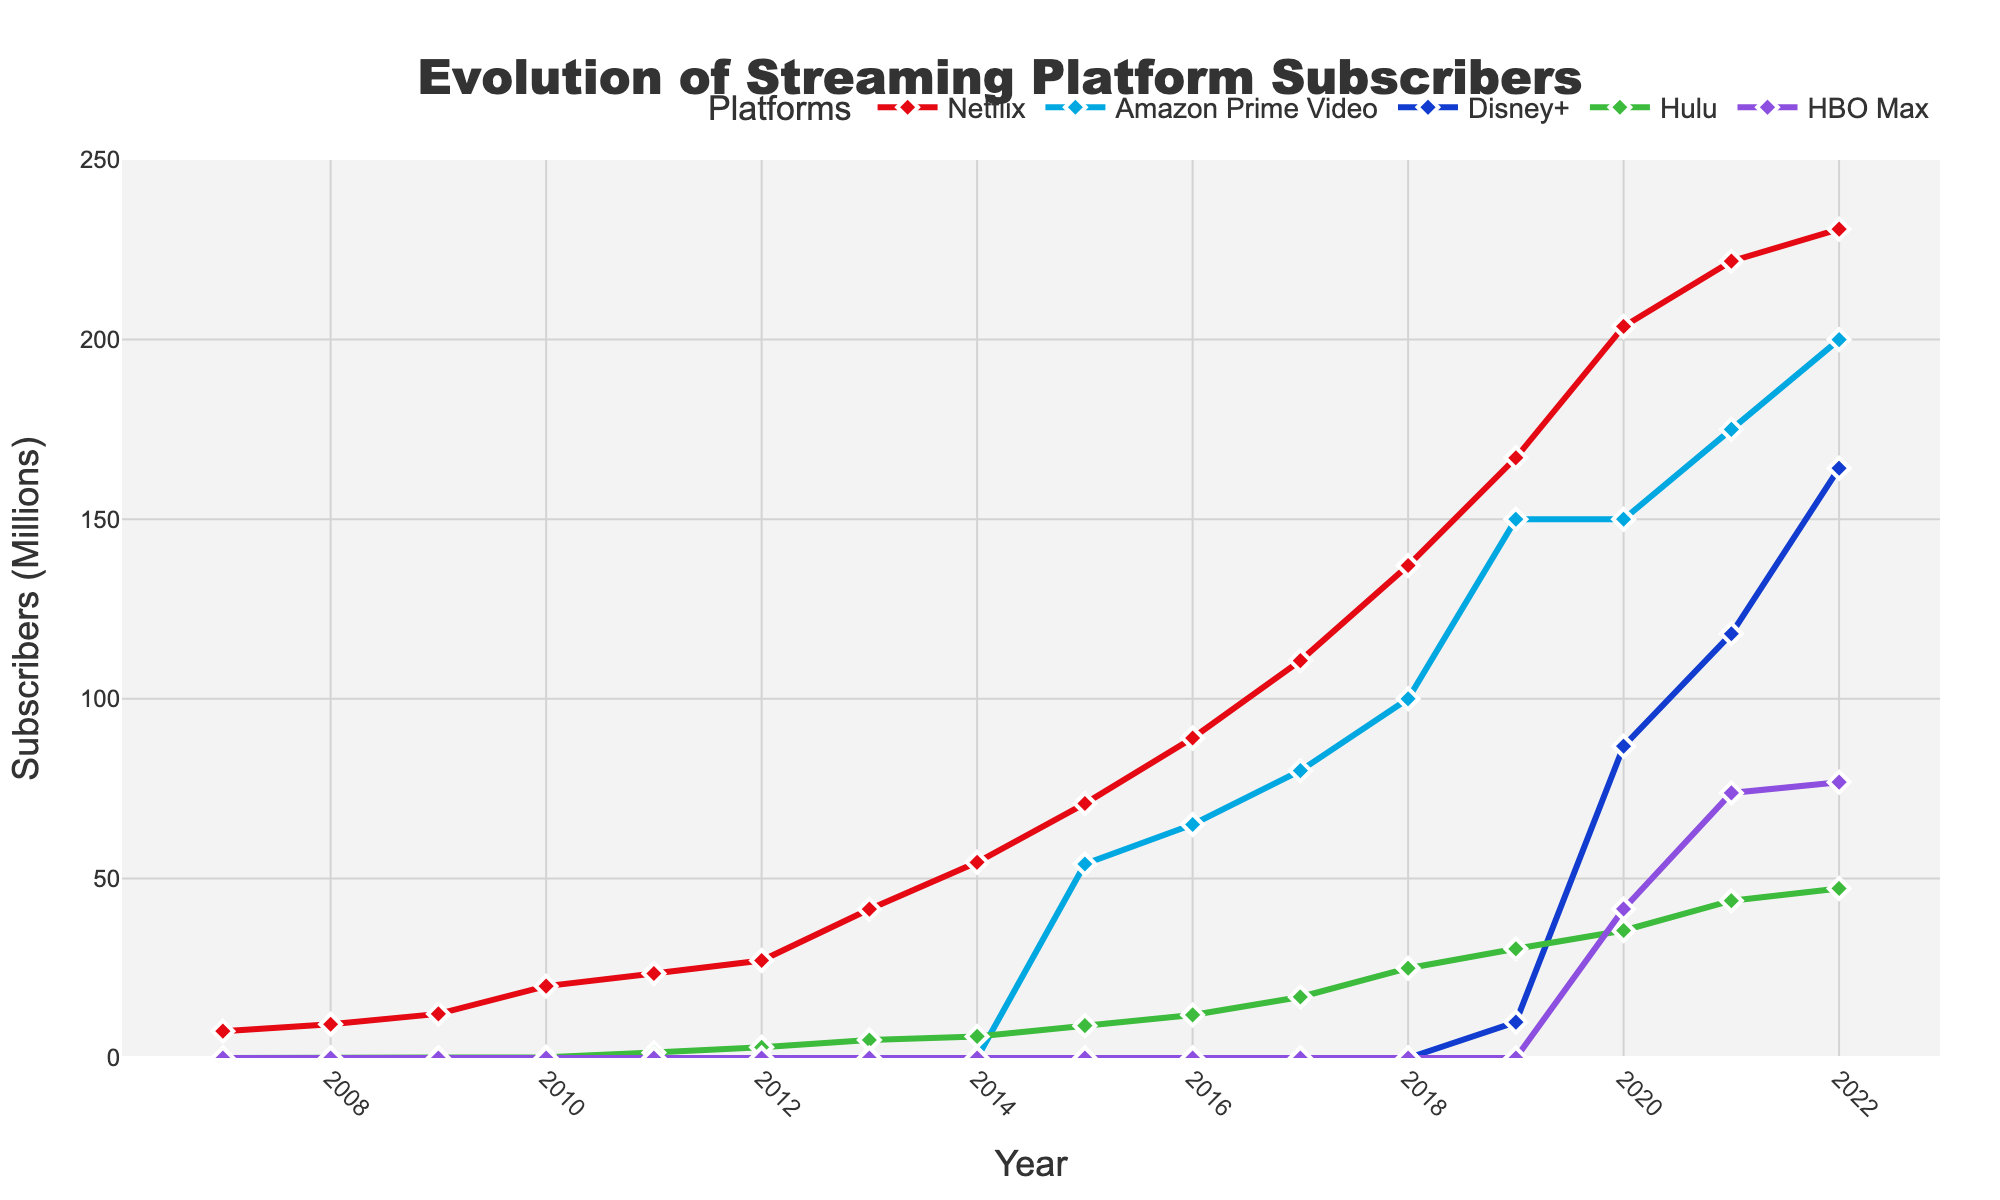What's the subscriber count for Disney+ in 2020? Check the data point for Disney+ in 2020 directly from the figure, which shows 86.8 million subscribers.
Answer: 86.8 million Which platform had the highest subscribers in 2022? Compare the subscriber counts for all platforms in 2022. Netflix has 230.75 million subscribers, which is higher than Amazon Prime Video (200 million), Disney+ (164.2 million), Hulu (47.2 million), and HBO Max (76.8 million).
Answer: Netflix How much did Hulu's subscribers grow from 2017 to 2019? Look at Hulu's subscriber count in 2017 (17 million) and 2019 (30.4 million). Subtract the 2017 value from the 2019 value: 30.4 - 17 = 13.4 million.
Answer: 13.4 million What was the combined total of subscribers for all platforms in 2021? Add the subscriber counts for all platforms in 2021: Netflix (221.84), Amazon Prime Video (175), Disney+ (118.1), Hulu (43.8), and HBO Max (73.8). The sum is 221.84 + 175 + 118.1 + 43.8 + 73.8 = 632.54 million.
Answer: 632.54 million Which platform experienced the fastest growth rate between 2019 and 2020? Calculate the growth rate for each platform by taking the difference between 2020 and 2019 subscriber counts and expressing it as a percentage of the 2019 counts: Netflix: (203.66 - 167.09) / 167.09 ≈ 21.9%, Amazon Prime Video: (150 - 150) / 150 = 0%, Disney+: (86.8 - 10) / 10 = 768%, Hulu: (35.5 - 30.4) / 30.4 ≈ 16.8%, HBO Max: (41.5 - 0) / 0 = undefined (new platform). Disney+ experienced the fastest growth rate of 768%.
Answer: Disney+ Which year saw the introduction of the most new streaming services according to the plot? Observe the platform subscriber lines in the figure. In 2020, both Disney+ and HBO Max show initial subscribers indicating their respective introductions. No other year has multiple new services making their first appearance.
Answer: 2020 By how much did Netflix's subscribers increase from 2007 to 2012? Compare Netflix's subscriber counts in 2007 (7.48 million) and 2012 (27.15 million). The increase is 27.15 - 7.48 = 19.67 million.
Answer: 19.67 million What can you say about the subscriber trend for Amazon Prime Video from 2015 to 2022? Examine the subscriber counts for Amazon Prime Video from 2015 (54 million) to 2022 (200 million). The trend shows a consistent increase every year.
Answer: Consistent increase 